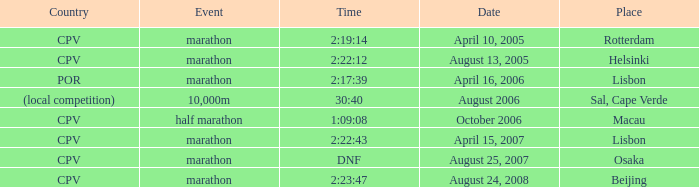What is the Place of the half marathon Event? Macau. 